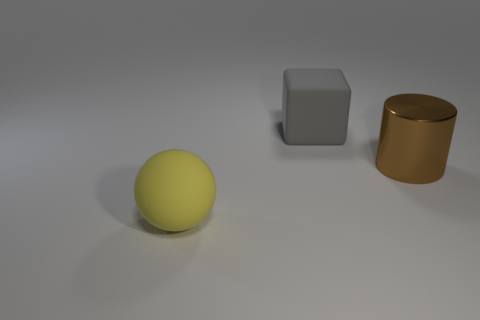What number of other objects are the same size as the gray matte object?
Keep it short and to the point. 2. There is a large object that is both on the left side of the big metal cylinder and behind the large sphere; what is its material?
Offer a very short reply. Rubber. Does the large metal cylinder have the same color as the large object that is behind the big shiny cylinder?
Offer a very short reply. No. What shape is the large object that is right of the large ball and on the left side of the brown metallic object?
Your answer should be very brief. Cube. There is a cylinder; is it the same size as the matte object that is behind the large yellow ball?
Make the answer very short. Yes. There is a rubber thing that is on the right side of the rubber sphere; is it the same size as the thing left of the big gray object?
Keep it short and to the point. Yes. Do the yellow object and the gray thing have the same shape?
Make the answer very short. No. What number of things are either big matte objects on the left side of the matte cube or tiny cylinders?
Keep it short and to the point. 1. Is there another large thing that has the same shape as the big gray thing?
Offer a terse response. No. Is the number of big cylinders in front of the gray matte thing the same as the number of big metal things?
Give a very brief answer. Yes. 